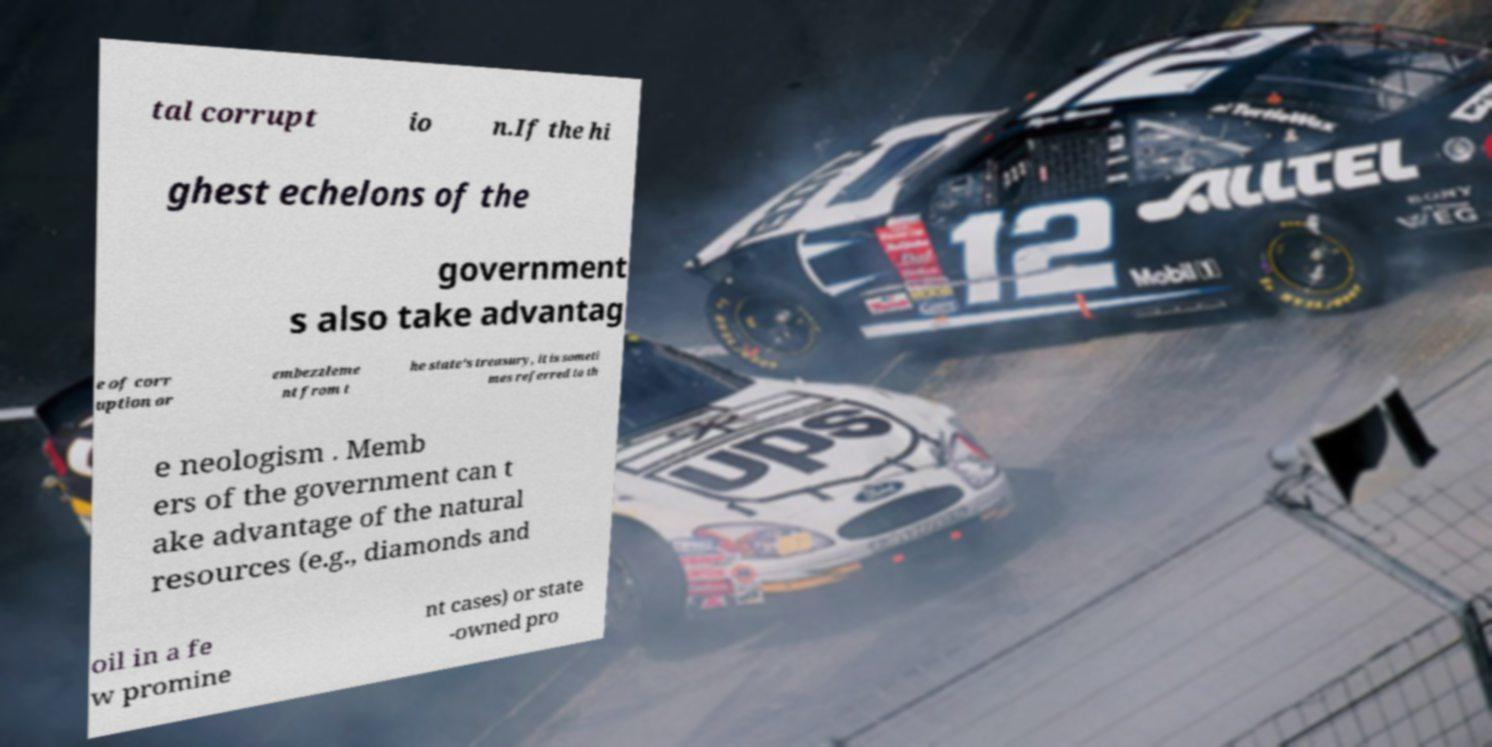Could you extract and type out the text from this image? tal corrupt io n.If the hi ghest echelons of the government s also take advantag e of corr uption or embezzleme nt from t he state's treasury, it is someti mes referred to th e neologism . Memb ers of the government can t ake advantage of the natural resources (e.g., diamonds and oil in a fe w promine nt cases) or state -owned pro 